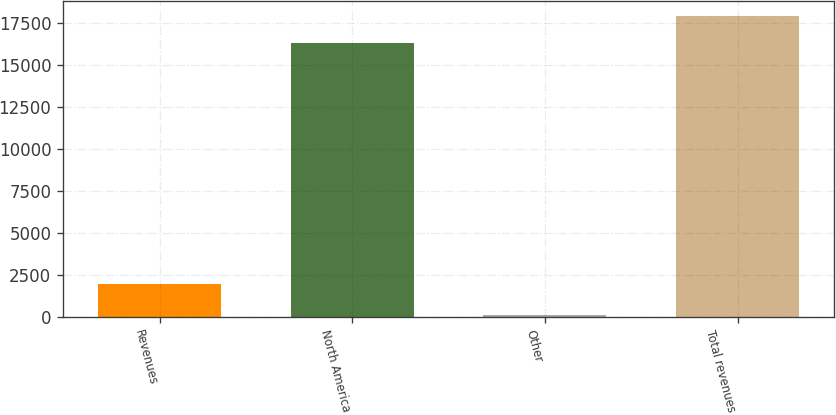Convert chart to OTSL. <chart><loc_0><loc_0><loc_500><loc_500><bar_chart><fcel>Revenues<fcel>North America<fcel>Other<fcel>Total revenues<nl><fcel>2002<fcel>16289<fcel>128<fcel>17917.9<nl></chart> 